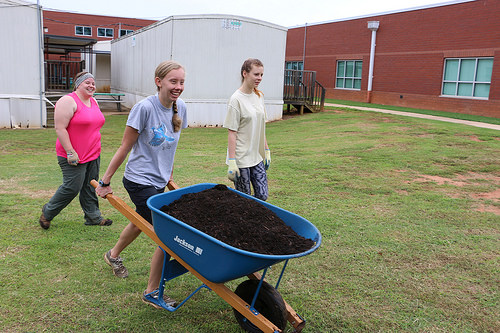<image>
Is there a girl on the wheelbarrow? No. The girl is not positioned on the wheelbarrow. They may be near each other, but the girl is not supported by or resting on top of the wheelbarrow. Is there a girl to the left of the school? No. The girl is not to the left of the school. From this viewpoint, they have a different horizontal relationship. Is the girl in front of the wheelbarrow? No. The girl is not in front of the wheelbarrow. The spatial positioning shows a different relationship between these objects. 